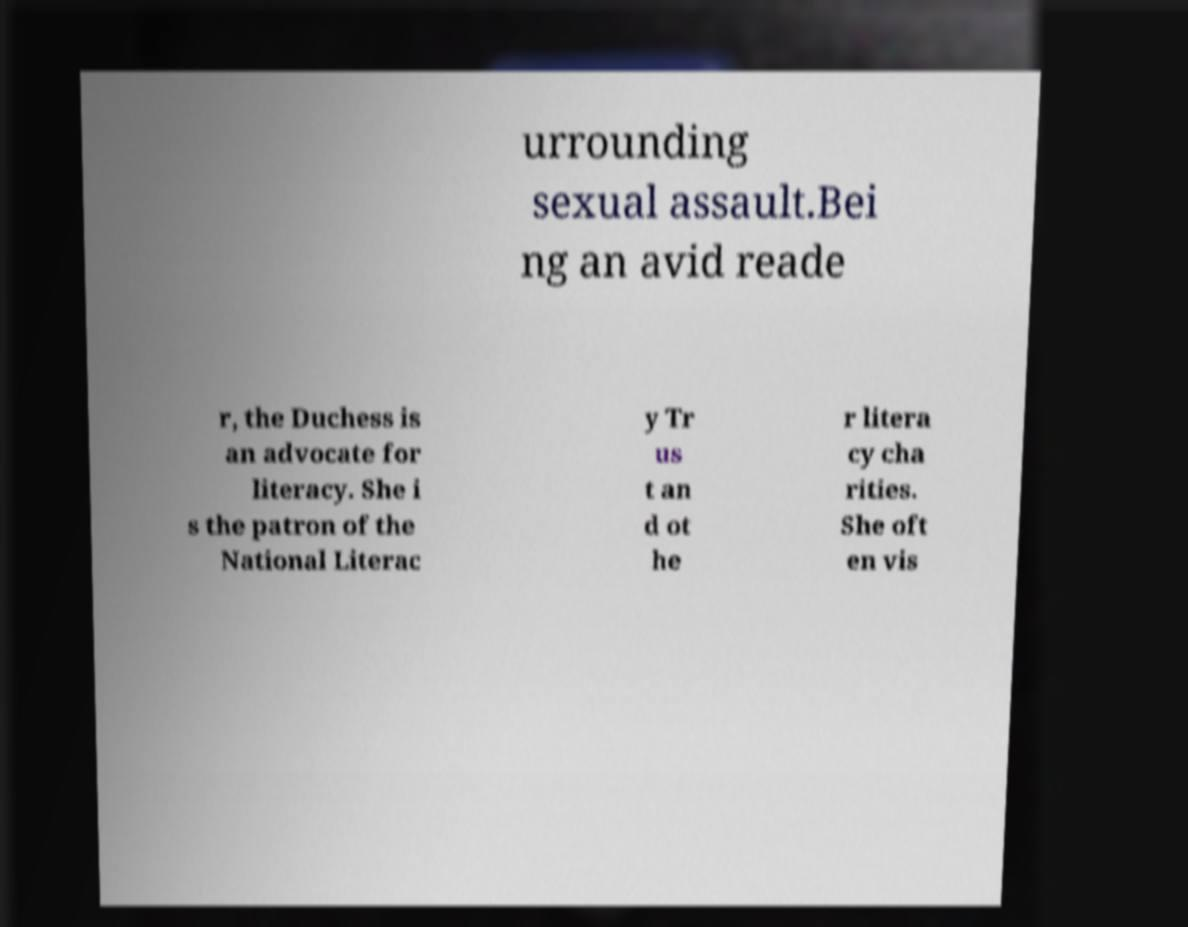Can you accurately transcribe the text from the provided image for me? urrounding sexual assault.Bei ng an avid reade r, the Duchess is an advocate for literacy. She i s the patron of the National Literac y Tr us t an d ot he r litera cy cha rities. She oft en vis 